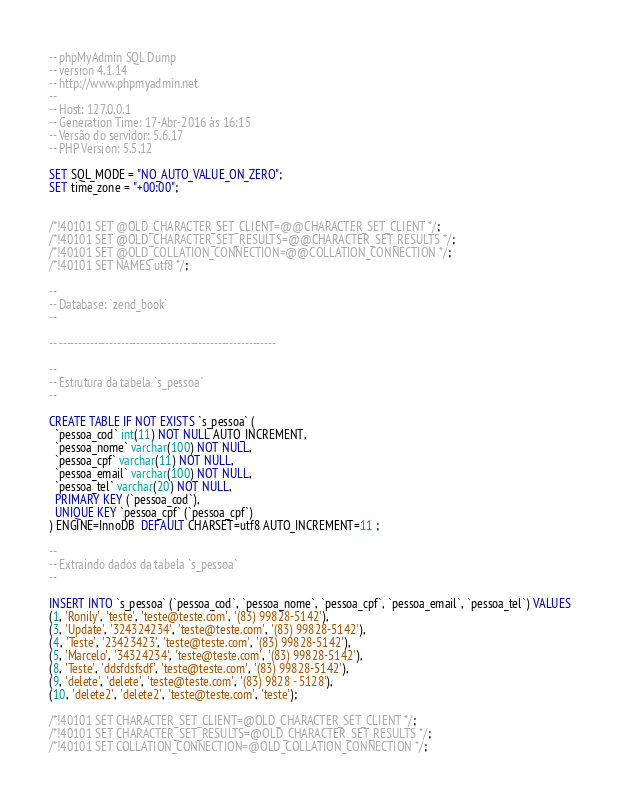Convert code to text. <code><loc_0><loc_0><loc_500><loc_500><_SQL_>-- phpMyAdmin SQL Dump
-- version 4.1.14
-- http://www.phpmyadmin.net
--
-- Host: 127.0.0.1
-- Generation Time: 17-Abr-2016 às 16:15
-- Versão do servidor: 5.6.17
-- PHP Version: 5.5.12

SET SQL_MODE = "NO_AUTO_VALUE_ON_ZERO";
SET time_zone = "+00:00";


/*!40101 SET @OLD_CHARACTER_SET_CLIENT=@@CHARACTER_SET_CLIENT */;
/*!40101 SET @OLD_CHARACTER_SET_RESULTS=@@CHARACTER_SET_RESULTS */;
/*!40101 SET @OLD_COLLATION_CONNECTION=@@COLLATION_CONNECTION */;
/*!40101 SET NAMES utf8 */;

--
-- Database: `zend_book`
--

-- --------------------------------------------------------

--
-- Estrutura da tabela `s_pessoa`
--

CREATE TABLE IF NOT EXISTS `s_pessoa` (
  `pessoa_cod` int(11) NOT NULL AUTO_INCREMENT,
  `pessoa_nome` varchar(100) NOT NULL,
  `pessoa_cpf` varchar(11) NOT NULL,
  `pessoa_email` varchar(100) NOT NULL,
  `pessoa_tel` varchar(20) NOT NULL,
  PRIMARY KEY (`pessoa_cod`),
  UNIQUE KEY `pessoa_cpf` (`pessoa_cpf`)
) ENGINE=InnoDB  DEFAULT CHARSET=utf8 AUTO_INCREMENT=11 ;

--
-- Extraindo dados da tabela `s_pessoa`
--

INSERT INTO `s_pessoa` (`pessoa_cod`, `pessoa_nome`, `pessoa_cpf`, `pessoa_email`, `pessoa_tel`) VALUES
(1, 'Ronily', 'teste', 'teste@teste.com', '(83) 99828-5142'),
(3, 'Update', '324324234', 'teste@teste.com', '(83) 99828-5142'),
(4, 'Teste', '23423423', 'teste@teste.com', '(83) 99828-5142'),
(5, 'Marcelo', '34324234', 'teste@teste.com', '(83) 99828-5142'),
(8, 'Teste', 'ddsfdsfsdf', 'teste@teste.com', '(83) 99828-5142'),
(9, 'delete', 'delete', 'teste@teste.com', '(83) 9828 - 5128'),
(10, 'delete2', 'delete2', 'teste@teste.com', 'teste');

/*!40101 SET CHARACTER_SET_CLIENT=@OLD_CHARACTER_SET_CLIENT */;
/*!40101 SET CHARACTER_SET_RESULTS=@OLD_CHARACTER_SET_RESULTS */;
/*!40101 SET COLLATION_CONNECTION=@OLD_COLLATION_CONNECTION */;
</code> 